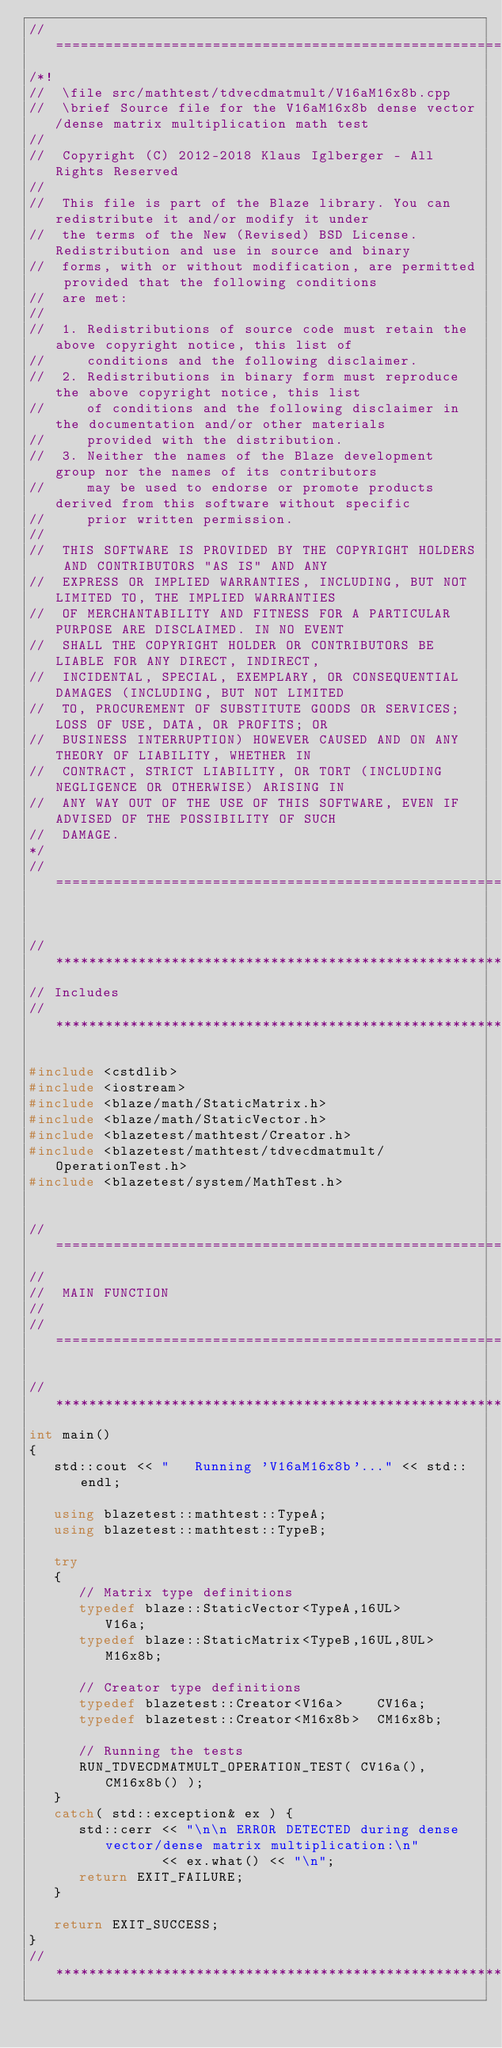Convert code to text. <code><loc_0><loc_0><loc_500><loc_500><_C++_>//=================================================================================================
/*!
//  \file src/mathtest/tdvecdmatmult/V16aM16x8b.cpp
//  \brief Source file for the V16aM16x8b dense vector/dense matrix multiplication math test
//
//  Copyright (C) 2012-2018 Klaus Iglberger - All Rights Reserved
//
//  This file is part of the Blaze library. You can redistribute it and/or modify it under
//  the terms of the New (Revised) BSD License. Redistribution and use in source and binary
//  forms, with or without modification, are permitted provided that the following conditions
//  are met:
//
//  1. Redistributions of source code must retain the above copyright notice, this list of
//     conditions and the following disclaimer.
//  2. Redistributions in binary form must reproduce the above copyright notice, this list
//     of conditions and the following disclaimer in the documentation and/or other materials
//     provided with the distribution.
//  3. Neither the names of the Blaze development group nor the names of its contributors
//     may be used to endorse or promote products derived from this software without specific
//     prior written permission.
//
//  THIS SOFTWARE IS PROVIDED BY THE COPYRIGHT HOLDERS AND CONTRIBUTORS "AS IS" AND ANY
//  EXPRESS OR IMPLIED WARRANTIES, INCLUDING, BUT NOT LIMITED TO, THE IMPLIED WARRANTIES
//  OF MERCHANTABILITY AND FITNESS FOR A PARTICULAR PURPOSE ARE DISCLAIMED. IN NO EVENT
//  SHALL THE COPYRIGHT HOLDER OR CONTRIBUTORS BE LIABLE FOR ANY DIRECT, INDIRECT,
//  INCIDENTAL, SPECIAL, EXEMPLARY, OR CONSEQUENTIAL DAMAGES (INCLUDING, BUT NOT LIMITED
//  TO, PROCUREMENT OF SUBSTITUTE GOODS OR SERVICES; LOSS OF USE, DATA, OR PROFITS; OR
//  BUSINESS INTERRUPTION) HOWEVER CAUSED AND ON ANY THEORY OF LIABILITY, WHETHER IN
//  CONTRACT, STRICT LIABILITY, OR TORT (INCLUDING NEGLIGENCE OR OTHERWISE) ARISING IN
//  ANY WAY OUT OF THE USE OF THIS SOFTWARE, EVEN IF ADVISED OF THE POSSIBILITY OF SUCH
//  DAMAGE.
*/
//=================================================================================================


//*************************************************************************************************
// Includes
//*************************************************************************************************

#include <cstdlib>
#include <iostream>
#include <blaze/math/StaticMatrix.h>
#include <blaze/math/StaticVector.h>
#include <blazetest/mathtest/Creator.h>
#include <blazetest/mathtest/tdvecdmatmult/OperationTest.h>
#include <blazetest/system/MathTest.h>


//=================================================================================================
//
//  MAIN FUNCTION
//
//=================================================================================================

//*************************************************************************************************
int main()
{
   std::cout << "   Running 'V16aM16x8b'..." << std::endl;

   using blazetest::mathtest::TypeA;
   using blazetest::mathtest::TypeB;

   try
   {
      // Matrix type definitions
      typedef blaze::StaticVector<TypeA,16UL>      V16a;
      typedef blaze::StaticMatrix<TypeB,16UL,8UL>  M16x8b;

      // Creator type definitions
      typedef blazetest::Creator<V16a>    CV16a;
      typedef blazetest::Creator<M16x8b>  CM16x8b;

      // Running the tests
      RUN_TDVECDMATMULT_OPERATION_TEST( CV16a(), CM16x8b() );
   }
   catch( std::exception& ex ) {
      std::cerr << "\n\n ERROR DETECTED during dense vector/dense matrix multiplication:\n"
                << ex.what() << "\n";
      return EXIT_FAILURE;
   }

   return EXIT_SUCCESS;
}
//*************************************************************************************************
</code> 